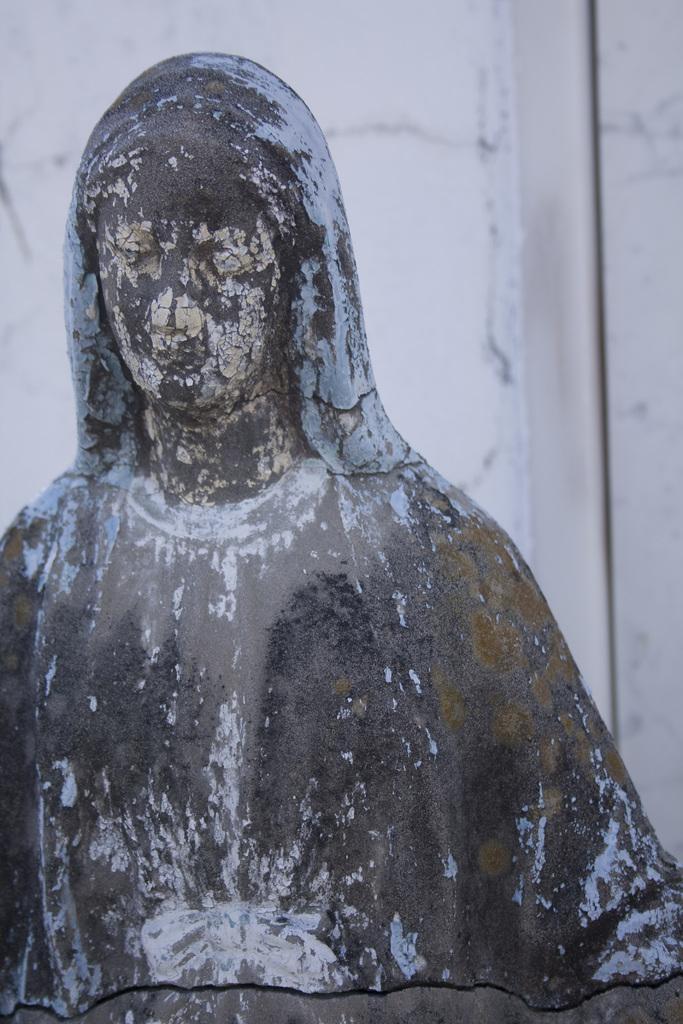Describe this image in one or two sentences. In the picture we can see a sculpture of a woman and behind it, we can see a wall which is white in color. 